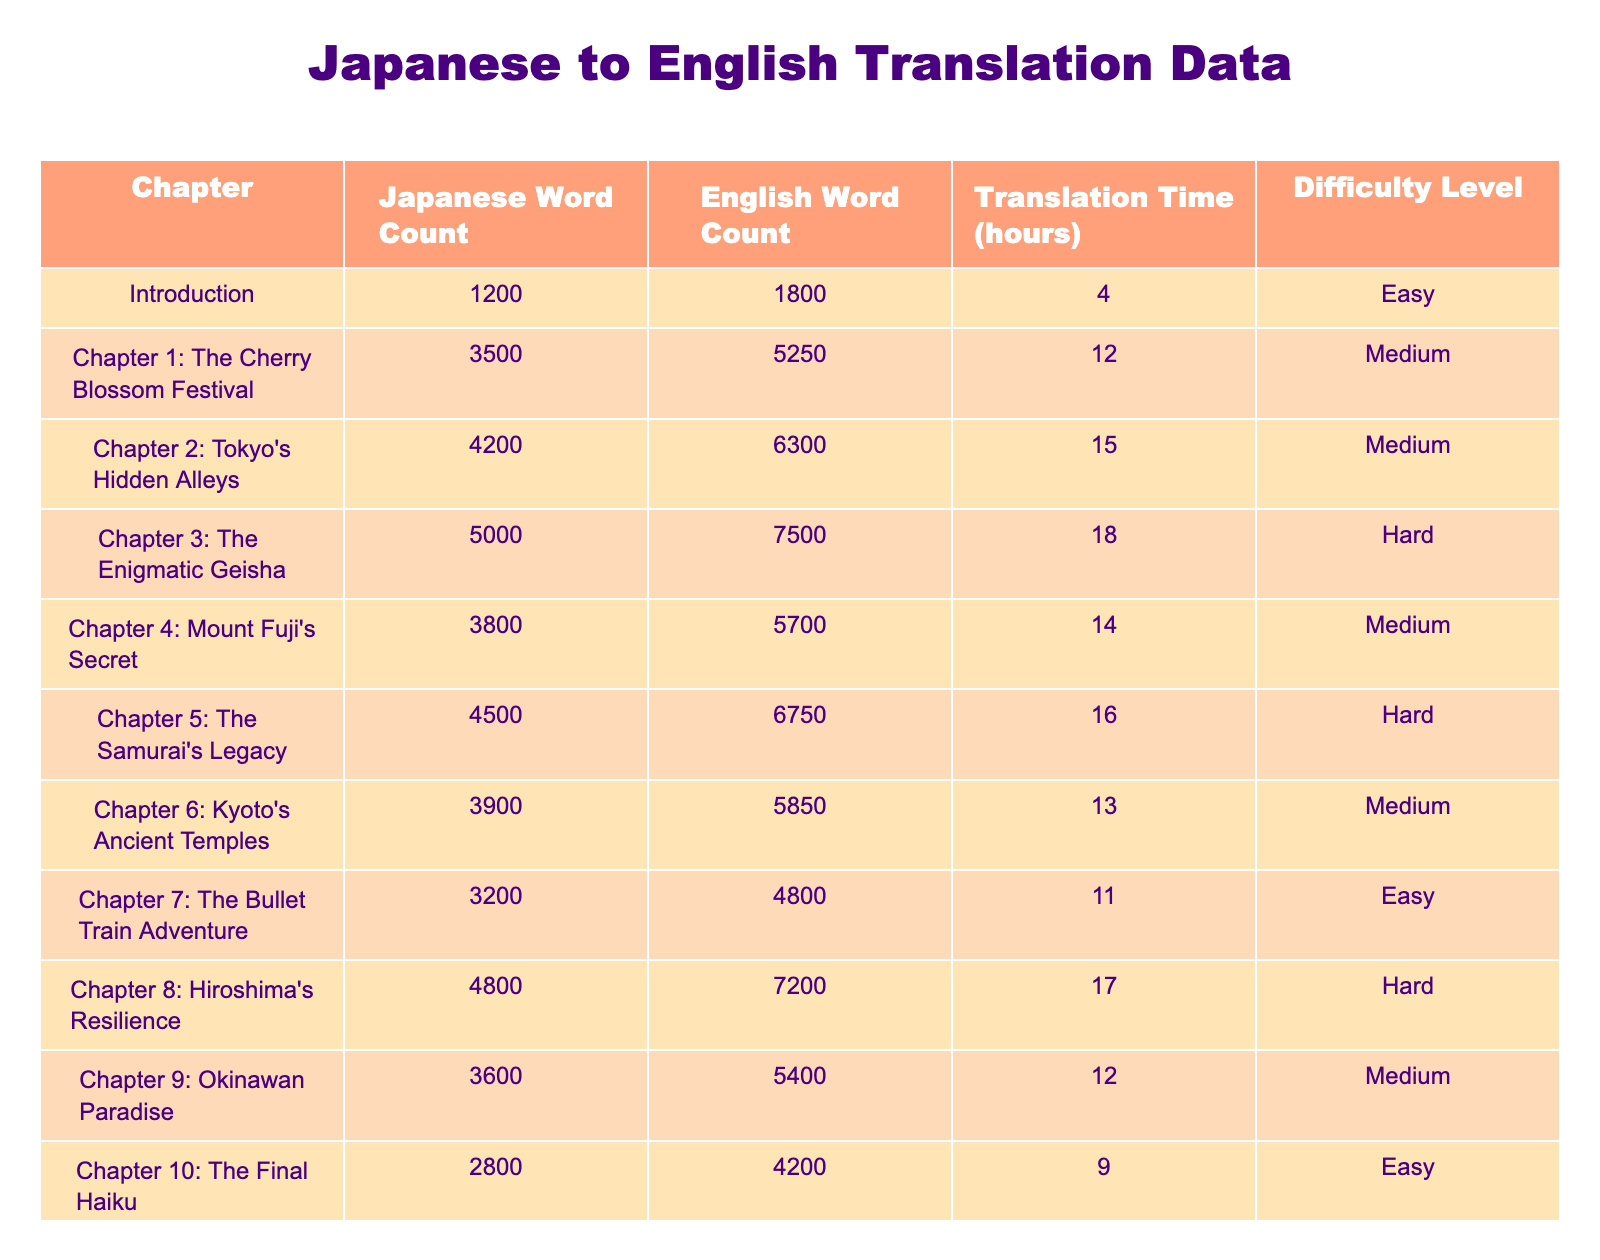What is the Japanese word count of Chapter 3? The table lists the Japanese word count for Chapter 3: The Enigmatic Geisha as 5000.
Answer: 5000 What is the English word count for the Introduction? The table shows the English word count for the Introduction as 1800.
Answer: 1800 How long did it take to translate Chapter 5? The translation time for Chapter 5: The Samurai's Legacy is listed as 16 hours.
Answer: 16 hours Which chapter has the highest difficulty level? The chapters with the highest difficulty level are Chapter 3 and Chapter 5, both categorized as Hard.
Answer: Chapter 3 and Chapter 5 What is the total Japanese word count across all chapters? To find the total, I sum the Japanese word counts: 1200 + 3500 + 4200 + 5000 + 3800 + 4500 + 3900 + 3200 + 4800 + 3600 + 2800 + 1500 =  42500.
Answer: 42500 What is the average translation time per chapter? To calculate the average translation time, I sum the translation times: 4 + 12 + 15 + 18 + 14 + 16 + 13 + 11 + 17 + 12 + 9 + 5 =  12.5 hours. Then divide by 12 chapters, which gives approximately 12.5/12 = 12.5 hours.
Answer: 12.5 hours Is the English word count for Chapter 2 greater than that of Chapter 10? The English word count for Chapter 2: Tokyo's Hidden Alleys is 6300, while for Chapter 10: The Final Haiku, it is 4200. Therefore, 6300 is greater than 4200, confirming that the statement is true.
Answer: Yes Which chapter has the lowest translation time? By examining the table, Chapter 10: The Final Haiku has the lowest translation time of 9 hours.
Answer: Chapter 10 How many chapters have a difficulty level of Medium? The chapters categorized as Medium are: Chapter 1, Chapter 2, Chapter 4, Chapter 6, Chapter 9. Counting these, there are 5 chapters with a difficulty level of Medium.
Answer: 5 chapters What is the difference between the Japanese word count of Chapter 4 and Chapter 6? The Japanese word count for Chapter 4: Mount Fuji's Secret is 3800, and for Chapter 6: Kyoto's Ancient Temples, it is 3900. The difference is 3900 - 3800 = 100.
Answer: 100 Which chapter has the second highest English word count? First, I note the English word counts for all chapters. The highest is Chapter 3 with 7500, and the second highest is Chapter 5 with 6750.
Answer: Chapter 5 